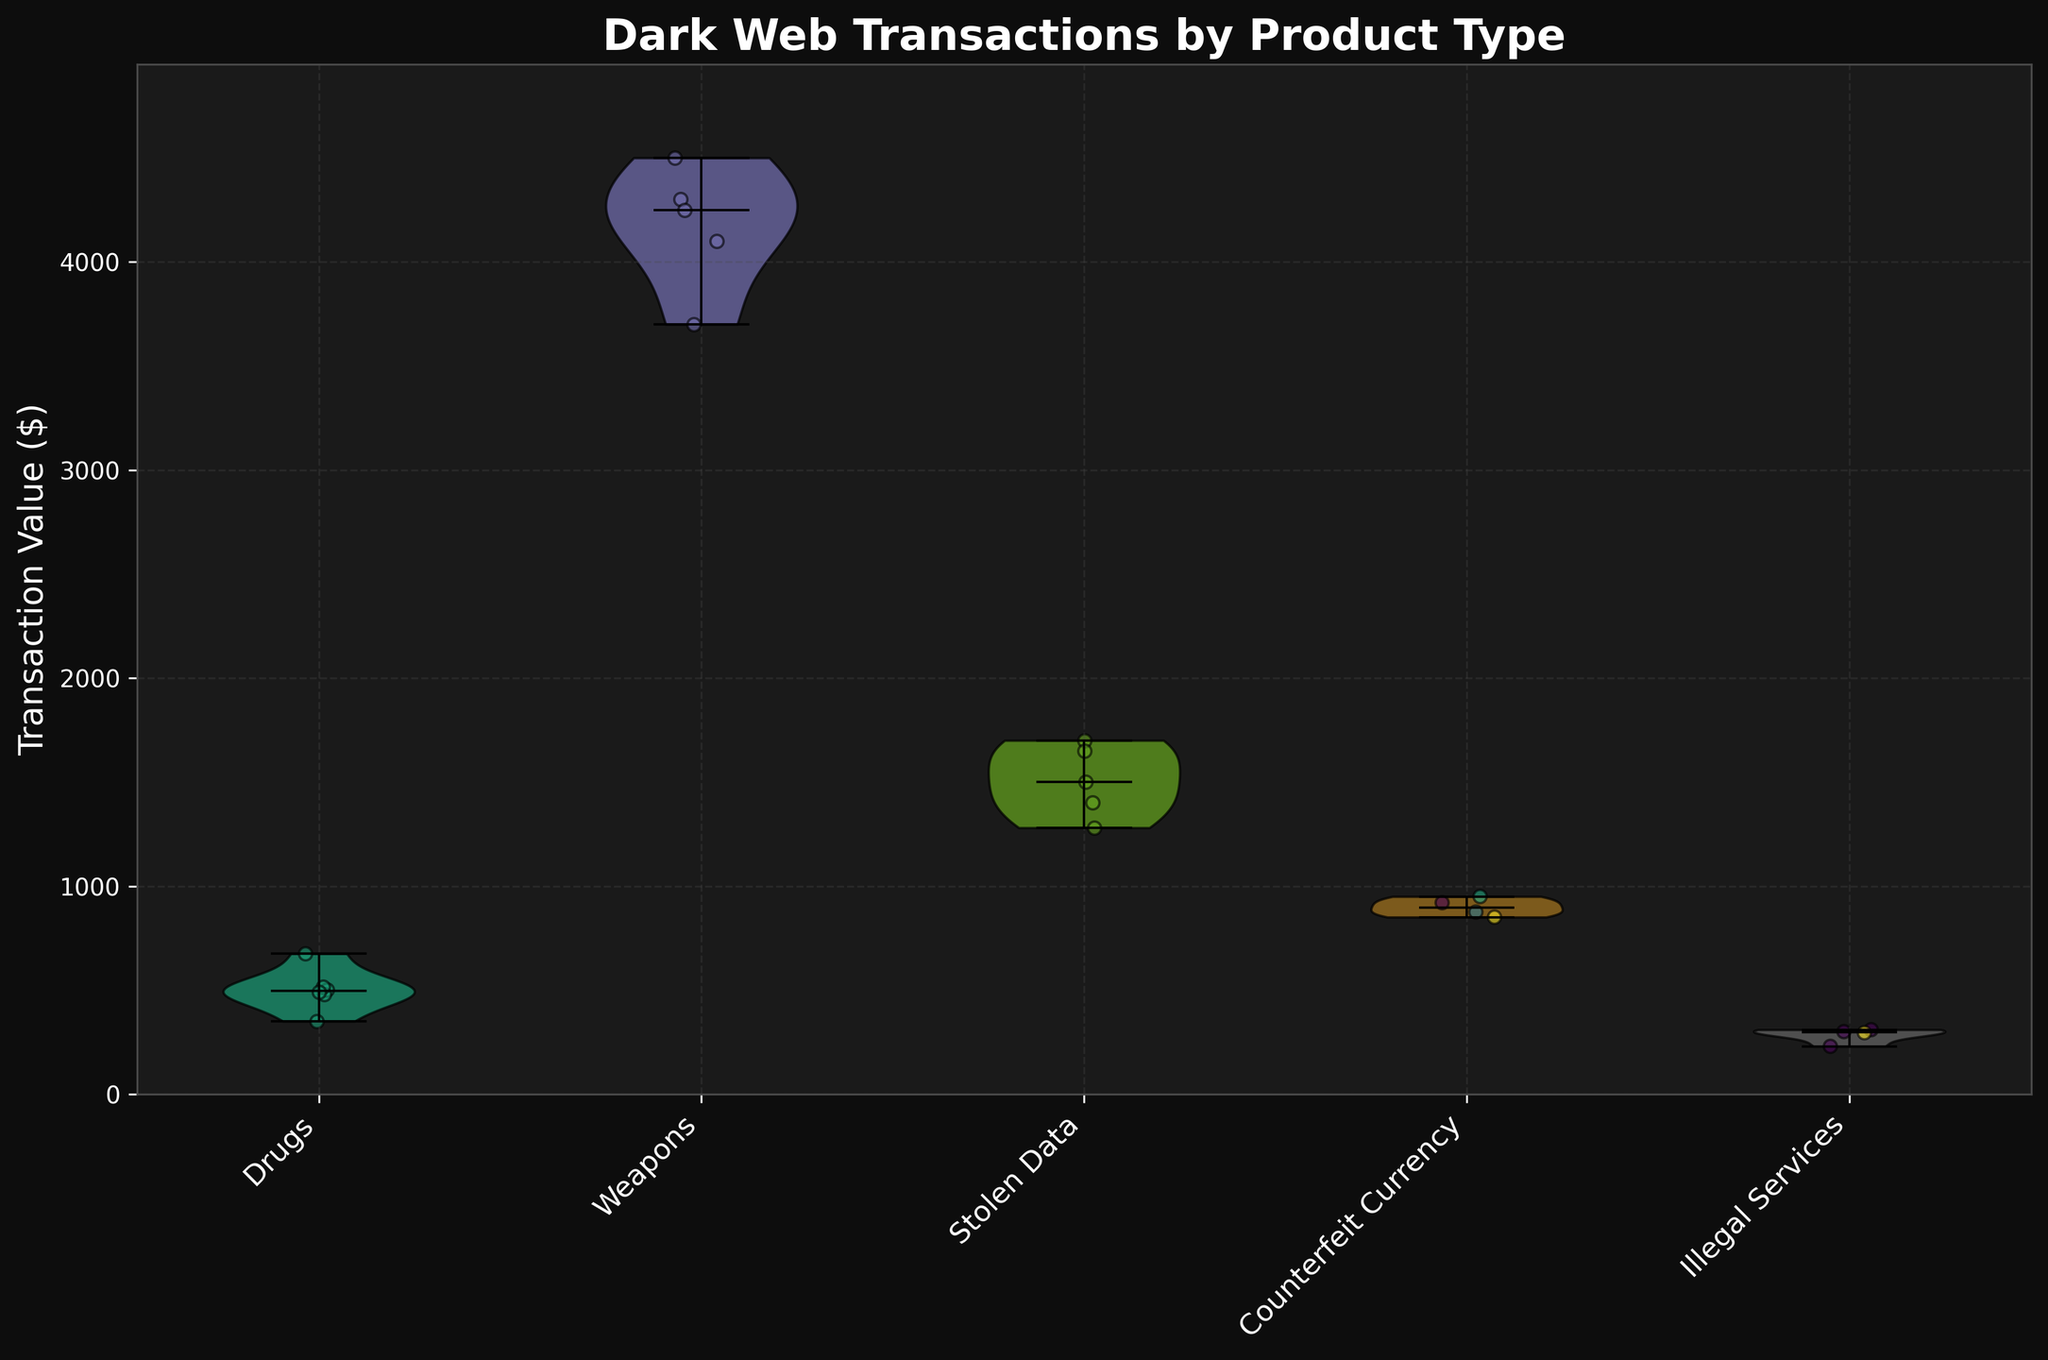Who has the highest median transaction value? By looking for the violin plot with the highest median line, we can see that 'Weapons' has the highest median transaction value.
Answer: Weapons What is the title of the figure? The title is typically found at the top or bottom of the figure in bold or large font. In this case, it reads "Dark Web Transactions by Product Type."
Answer: Dark Web Transactions by Product Type Which product type has the most variability in transaction values? Variability in violin plots is indicated by the width of the plot. The wider the plot, the more variable the transaction values. 'Weapons' has the widest violin plot, indicating the most variability.
Answer: Weapons How many different product types are shown in the figure? By counting the distinct labels on the x-axis of the figure, we can see there are six different product types.
Answer: Six Which product type has the lowest maximum transaction value? From examining the highest points on each violin plot, we see that 'Illegal Services' has the lowest maximum value.
Answer: Illegal Services Which product type has a median transaction value that is higher than 'Drugs' but lower than 'Weapons'? To find this, we compare the median lines of the product types. 'Stolen Data' has a median higher than 'Drugs' but lower than 'Weapons'.
Answer: Stolen Data What is the range of transaction values for 'Counterfeit Currency'? The range is the difference between the highest and lowest points on the violin plot. From the plot, the lowest is around 850 and the highest is near 950. Thus, the range is approximately from 850 to 950.
Answer: ~850 to 950 Which product type shows more frequent transactions at lower values? By looking at the density of jittered points, 'Illegal Services' has more transactions clustered towards lower values.
Answer: Illegal Services Is there a noticeable trend in transaction values for 'Drugs'? The violin plot is relatively consistent without extreme peaks or troughs, suggesting that transaction values for 'Drugs' are fairly stable.
Answer: Stable Among the product types, which one has the next highest median after 'Weapons'? By checking each violin plot's median line, after 'Weapons', the next highest median belongs to 'Stolen Data'.
Answer: Stolen Data 